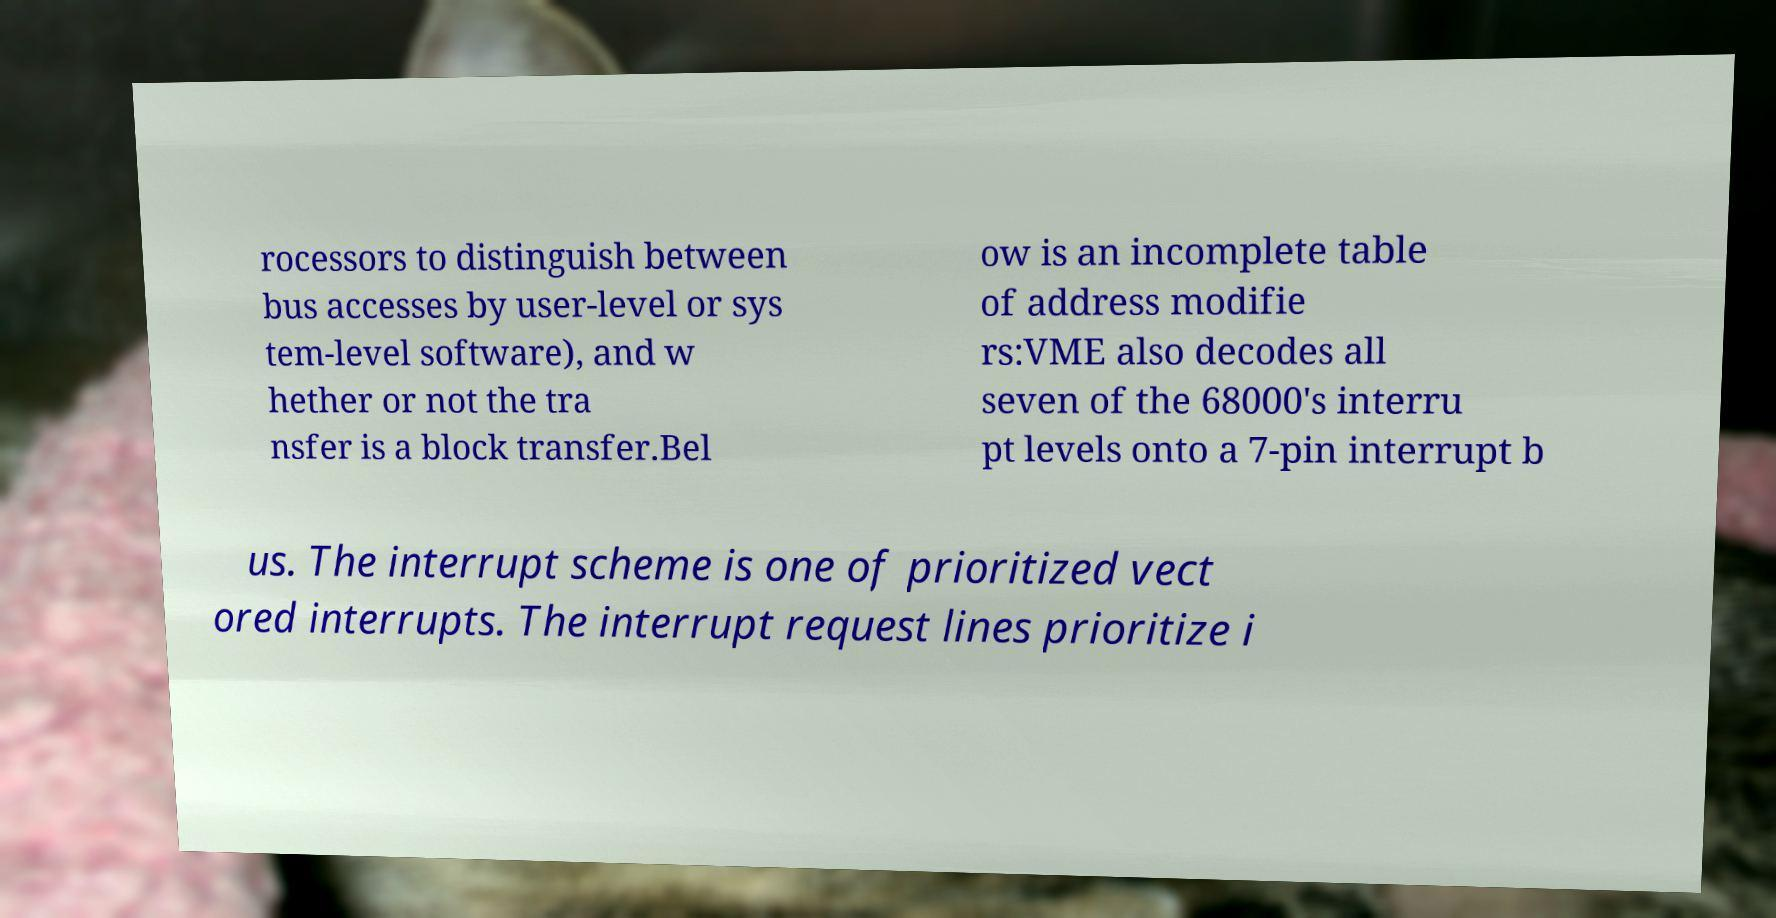I need the written content from this picture converted into text. Can you do that? rocessors to distinguish between bus accesses by user-level or sys tem-level software), and w hether or not the tra nsfer is a block transfer.Bel ow is an incomplete table of address modifie rs:VME also decodes all seven of the 68000's interru pt levels onto a 7-pin interrupt b us. The interrupt scheme is one of prioritized vect ored interrupts. The interrupt request lines prioritize i 